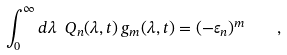Convert formula to latex. <formula><loc_0><loc_0><loc_500><loc_500>\int _ { 0 } ^ { \infty } d \lambda \ Q _ { n } ( \lambda , t ) \, g _ { m } ( \lambda , t ) = ( - \varepsilon _ { n } ) ^ { m } \quad ,</formula> 